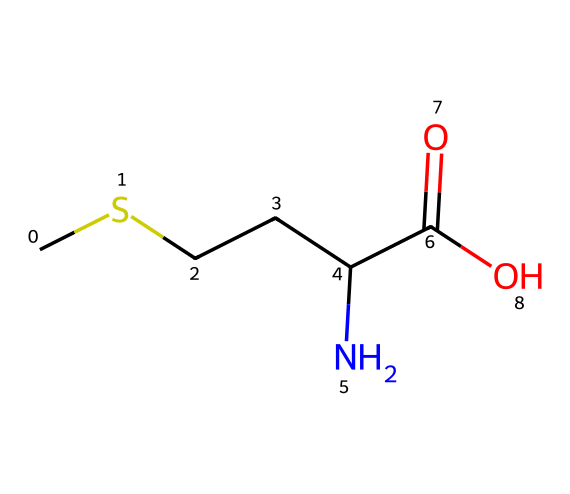What is the name of this compound? The structure corresponds to an amino acid classified as a sulfur-containing essential amino acid. It is specifically known as methionine.
Answer: methionine How many carbon atoms are in methionine? By examining the SMILES representation, there are four carbon atoms (C) present in the chain denoted before the nitrogen and the carboxylic group.
Answer: 4 What functional groups are present in methionine? The SMILES shows a carboxylic acid group (C(=O)O) at one end and an amino group (N) at another, both indicating that it is an amino acid.
Answer: carboxylic acid and amino Which atom in methionine is responsible for its sulfur-containing property? The 'S' in the structure indicates the presence of a sulfur atom, which is essential for the properties of methionine as a sulfur-containing amino acid.
Answer: sulfur What type of compound is methionine classified as? As methionine contains both an amine and a carboxylic acid functional group in its structure, it is classified as an amino acid.
Answer: amino acid How many hydrogen atoms are present in methionine? Each carbon and nitrogen atom typically bonds with enough hydrogens to fill their respective valences. In total, there are 7 hydrogen atoms observed when analyzing the structure.
Answer: 7 